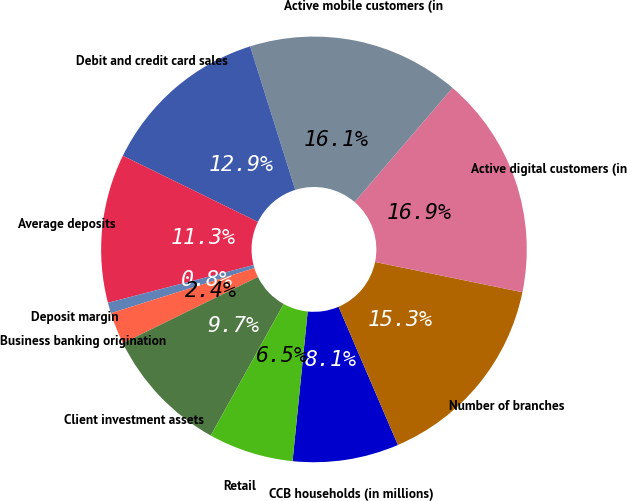Convert chart to OTSL. <chart><loc_0><loc_0><loc_500><loc_500><pie_chart><fcel>CCB households (in millions)<fcel>Number of branches<fcel>Active digital customers (in<fcel>Active mobile customers (in<fcel>Debit and credit card sales<fcel>Average deposits<fcel>Deposit margin<fcel>Business banking origination<fcel>Client investment assets<fcel>Retail<nl><fcel>8.06%<fcel>15.32%<fcel>16.94%<fcel>16.13%<fcel>12.9%<fcel>11.29%<fcel>0.81%<fcel>2.42%<fcel>9.68%<fcel>6.45%<nl></chart> 